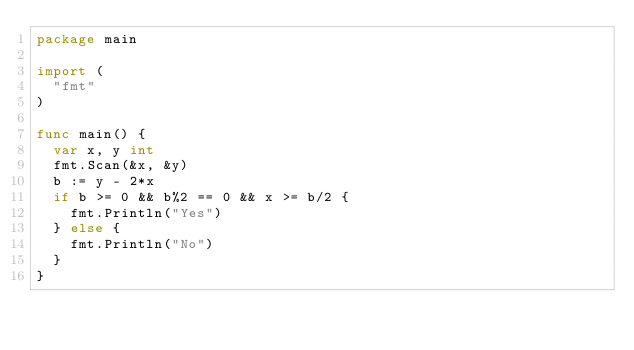<code> <loc_0><loc_0><loc_500><loc_500><_Go_>package main

import (
	"fmt"
)

func main() {
	var x, y int
	fmt.Scan(&x, &y)
	b := y - 2*x
	if b >= 0 && b%2 == 0 && x >= b/2 {
		fmt.Println("Yes")
	} else {
		fmt.Println("No")
	}
}
</code> 